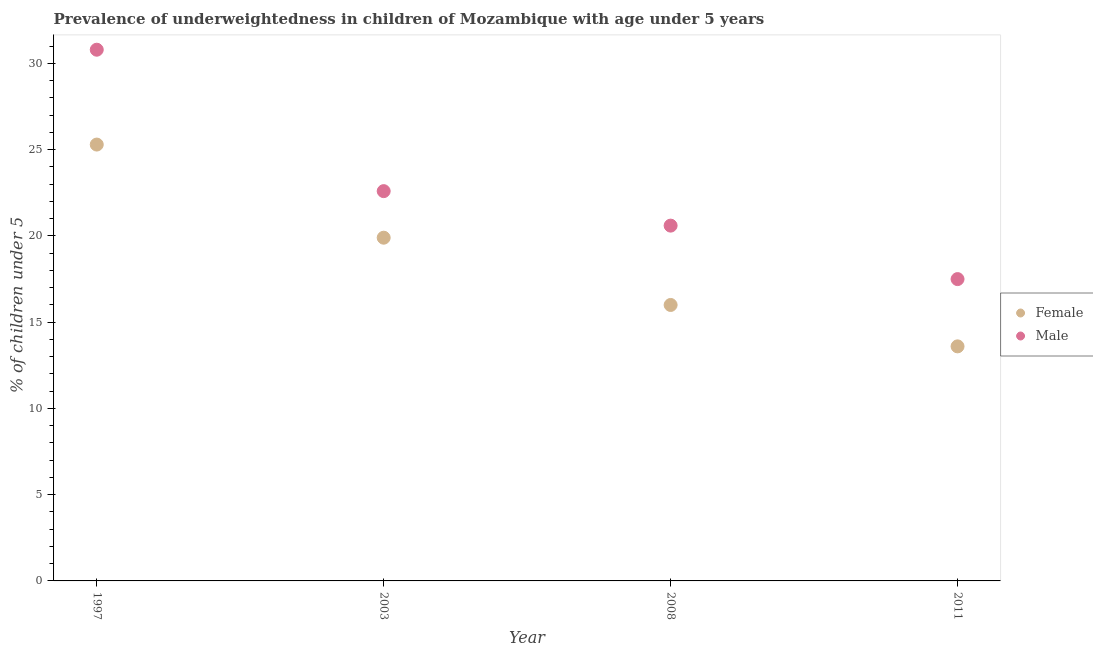What is the percentage of underweighted male children in 1997?
Make the answer very short. 30.8. Across all years, what is the maximum percentage of underweighted male children?
Offer a very short reply. 30.8. Across all years, what is the minimum percentage of underweighted male children?
Your answer should be very brief. 17.5. What is the total percentage of underweighted male children in the graph?
Your answer should be compact. 91.5. What is the difference between the percentage of underweighted female children in 1997 and that in 2011?
Your answer should be very brief. 11.7. What is the difference between the percentage of underweighted female children in 1997 and the percentage of underweighted male children in 2003?
Keep it short and to the point. 2.7. What is the average percentage of underweighted male children per year?
Keep it short and to the point. 22.87. In the year 2003, what is the difference between the percentage of underweighted female children and percentage of underweighted male children?
Your answer should be compact. -2.7. What is the ratio of the percentage of underweighted male children in 2003 to that in 2011?
Provide a succinct answer. 1.29. Is the percentage of underweighted female children in 2003 less than that in 2008?
Give a very brief answer. No. Is the difference between the percentage of underweighted male children in 1997 and 2008 greater than the difference between the percentage of underweighted female children in 1997 and 2008?
Offer a very short reply. Yes. What is the difference between the highest and the second highest percentage of underweighted female children?
Make the answer very short. 5.4. What is the difference between the highest and the lowest percentage of underweighted female children?
Provide a short and direct response. 11.7. In how many years, is the percentage of underweighted male children greater than the average percentage of underweighted male children taken over all years?
Offer a terse response. 1. Is the sum of the percentage of underweighted female children in 2003 and 2011 greater than the maximum percentage of underweighted male children across all years?
Your answer should be very brief. Yes. Does the percentage of underweighted male children monotonically increase over the years?
Provide a short and direct response. No. Is the percentage of underweighted male children strictly greater than the percentage of underweighted female children over the years?
Keep it short and to the point. Yes. How many dotlines are there?
Provide a short and direct response. 2. Does the graph contain grids?
Ensure brevity in your answer.  No. How many legend labels are there?
Your response must be concise. 2. How are the legend labels stacked?
Your answer should be compact. Vertical. What is the title of the graph?
Keep it short and to the point. Prevalence of underweightedness in children of Mozambique with age under 5 years. Does "Female entrants" appear as one of the legend labels in the graph?
Offer a terse response. No. What is the label or title of the X-axis?
Your response must be concise. Year. What is the label or title of the Y-axis?
Your answer should be very brief.  % of children under 5. What is the  % of children under 5 in Female in 1997?
Your response must be concise. 25.3. What is the  % of children under 5 of Male in 1997?
Your answer should be very brief. 30.8. What is the  % of children under 5 of Female in 2003?
Ensure brevity in your answer.  19.9. What is the  % of children under 5 of Male in 2003?
Your response must be concise. 22.6. What is the  % of children under 5 of Male in 2008?
Offer a very short reply. 20.6. What is the  % of children under 5 in Female in 2011?
Give a very brief answer. 13.6. Across all years, what is the maximum  % of children under 5 of Female?
Keep it short and to the point. 25.3. Across all years, what is the maximum  % of children under 5 of Male?
Ensure brevity in your answer.  30.8. Across all years, what is the minimum  % of children under 5 of Female?
Provide a succinct answer. 13.6. Across all years, what is the minimum  % of children under 5 in Male?
Your response must be concise. 17.5. What is the total  % of children under 5 in Female in the graph?
Provide a short and direct response. 74.8. What is the total  % of children under 5 of Male in the graph?
Your response must be concise. 91.5. What is the difference between the  % of children under 5 of Male in 1997 and that in 2008?
Give a very brief answer. 10.2. What is the difference between the  % of children under 5 of Female in 2008 and the  % of children under 5 of Male in 2011?
Give a very brief answer. -1.5. What is the average  % of children under 5 of Female per year?
Provide a succinct answer. 18.7. What is the average  % of children under 5 of Male per year?
Ensure brevity in your answer.  22.88. In the year 1997, what is the difference between the  % of children under 5 of Female and  % of children under 5 of Male?
Give a very brief answer. -5.5. In the year 2011, what is the difference between the  % of children under 5 in Female and  % of children under 5 in Male?
Provide a succinct answer. -3.9. What is the ratio of the  % of children under 5 of Female in 1997 to that in 2003?
Keep it short and to the point. 1.27. What is the ratio of the  % of children under 5 of Male in 1997 to that in 2003?
Make the answer very short. 1.36. What is the ratio of the  % of children under 5 of Female in 1997 to that in 2008?
Give a very brief answer. 1.58. What is the ratio of the  % of children under 5 of Male in 1997 to that in 2008?
Make the answer very short. 1.5. What is the ratio of the  % of children under 5 in Female in 1997 to that in 2011?
Your answer should be compact. 1.86. What is the ratio of the  % of children under 5 of Male in 1997 to that in 2011?
Give a very brief answer. 1.76. What is the ratio of the  % of children under 5 in Female in 2003 to that in 2008?
Provide a short and direct response. 1.24. What is the ratio of the  % of children under 5 in Male in 2003 to that in 2008?
Make the answer very short. 1.1. What is the ratio of the  % of children under 5 of Female in 2003 to that in 2011?
Offer a terse response. 1.46. What is the ratio of the  % of children under 5 in Male in 2003 to that in 2011?
Your answer should be very brief. 1.29. What is the ratio of the  % of children under 5 in Female in 2008 to that in 2011?
Your response must be concise. 1.18. What is the ratio of the  % of children under 5 of Male in 2008 to that in 2011?
Provide a short and direct response. 1.18. What is the difference between the highest and the second highest  % of children under 5 of Male?
Ensure brevity in your answer.  8.2. 